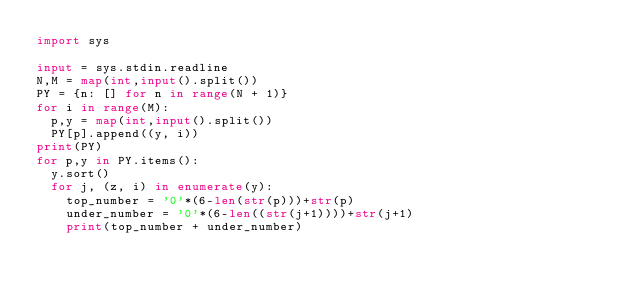<code> <loc_0><loc_0><loc_500><loc_500><_Python_>import sys

input = sys.stdin.readline
N,M = map(int,input().split())
PY = {n: [] for n in range(N + 1)}
for i in range(M):
  p,y = map(int,input().split())
  PY[p].append((y, i))
print(PY)
for p,y in PY.items():
  y.sort()
  for j, (z, i) in enumerate(y):
    top_number = '0'*(6-len(str(p)))+str(p)
    under_number = '0'*(6-len((str(j+1))))+str(j+1)
    print(top_number + under_number)</code> 